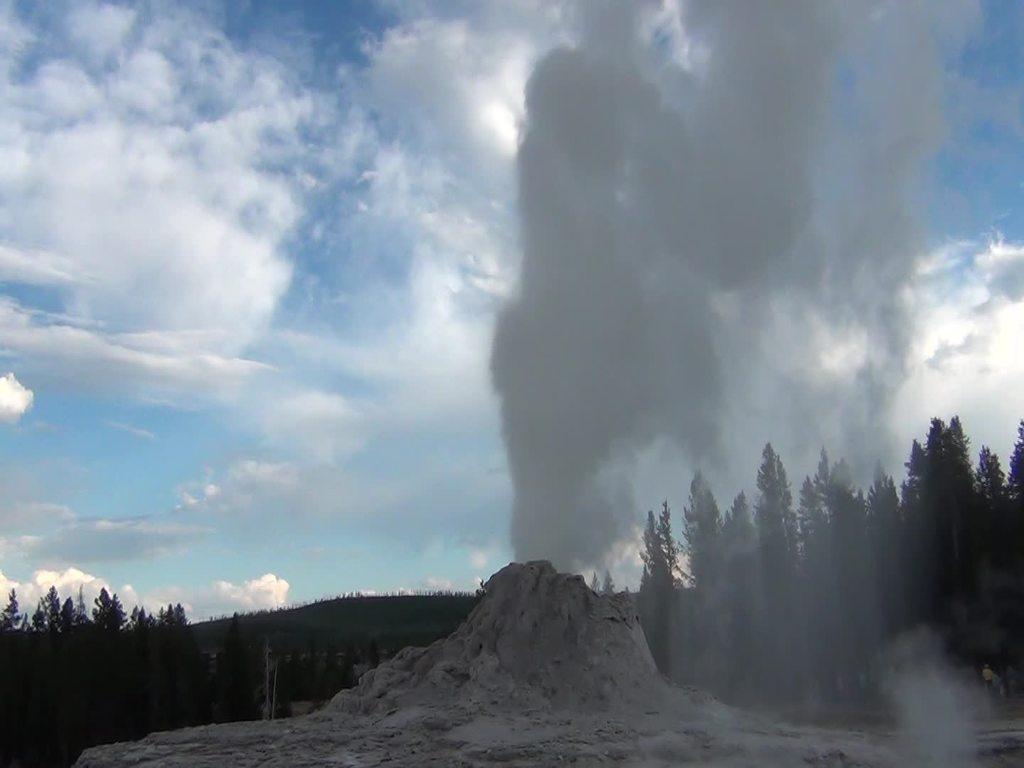Describe this image in one or two sentences. In this image I can see trees, smoke, sand and cloudy sky. 